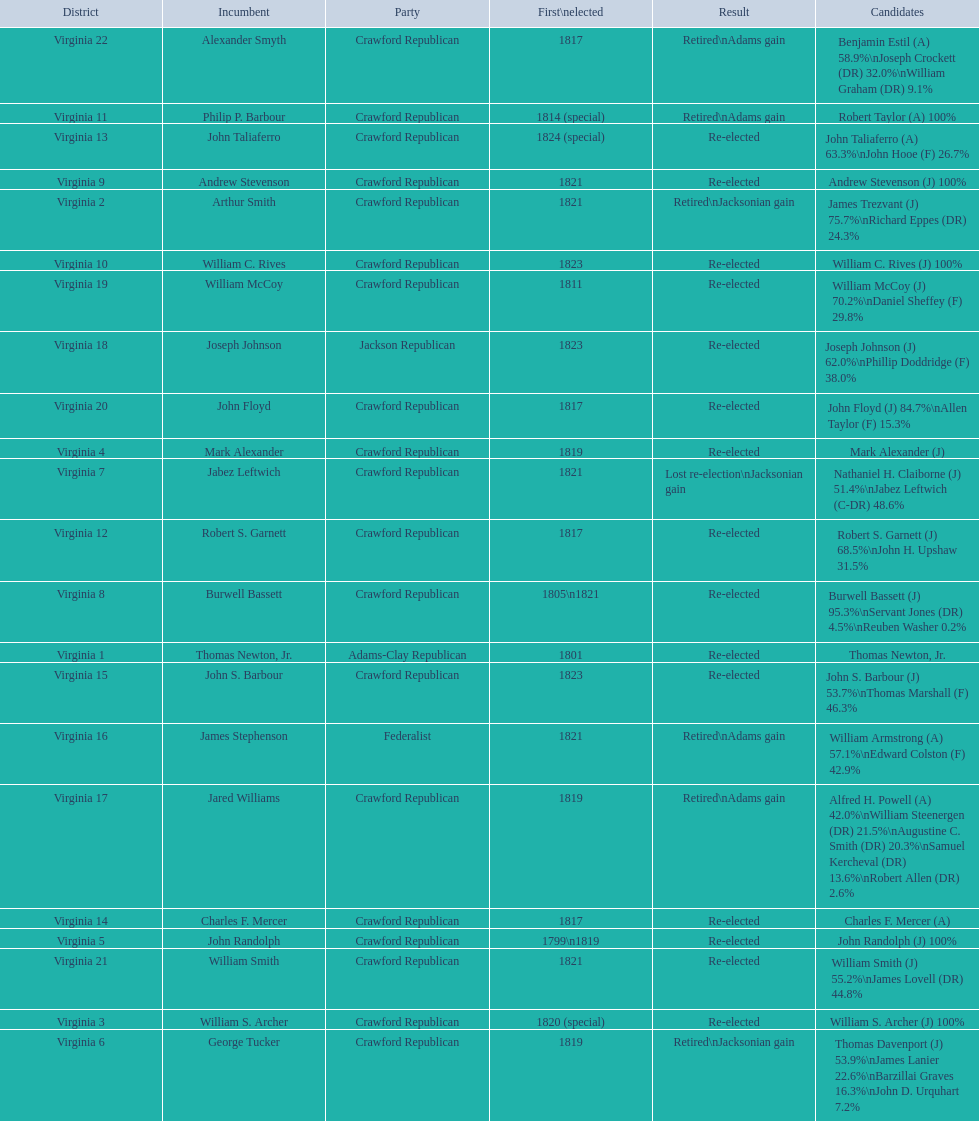Who were the incumbents of the 1824 united states house of representatives elections? Thomas Newton, Jr., Arthur Smith, William S. Archer, Mark Alexander, John Randolph, George Tucker, Jabez Leftwich, Burwell Bassett, Andrew Stevenson, William C. Rives, Philip P. Barbour, Robert S. Garnett, John Taliaferro, Charles F. Mercer, John S. Barbour, James Stephenson, Jared Williams, Joseph Johnson, William McCoy, John Floyd, William Smith, Alexander Smyth. And who were the candidates? Thomas Newton, Jr., James Trezvant (J) 75.7%\nRichard Eppes (DR) 24.3%, William S. Archer (J) 100%, Mark Alexander (J), John Randolph (J) 100%, Thomas Davenport (J) 53.9%\nJames Lanier 22.6%\nBarzillai Graves 16.3%\nJohn D. Urquhart 7.2%, Nathaniel H. Claiborne (J) 51.4%\nJabez Leftwich (C-DR) 48.6%, Burwell Bassett (J) 95.3%\nServant Jones (DR) 4.5%\nReuben Washer 0.2%, Andrew Stevenson (J) 100%, William C. Rives (J) 100%, Robert Taylor (A) 100%, Robert S. Garnett (J) 68.5%\nJohn H. Upshaw 31.5%, John Taliaferro (A) 63.3%\nJohn Hooe (F) 26.7%, Charles F. Mercer (A), John S. Barbour (J) 53.7%\nThomas Marshall (F) 46.3%, William Armstrong (A) 57.1%\nEdward Colston (F) 42.9%, Alfred H. Powell (A) 42.0%\nWilliam Steenergen (DR) 21.5%\nAugustine C. Smith (DR) 20.3%\nSamuel Kercheval (DR) 13.6%\nRobert Allen (DR) 2.6%, Joseph Johnson (J) 62.0%\nPhillip Doddridge (F) 38.0%, William McCoy (J) 70.2%\nDaniel Sheffey (F) 29.8%, John Floyd (J) 84.7%\nAllen Taylor (F) 15.3%, William Smith (J) 55.2%\nJames Lovell (DR) 44.8%, Benjamin Estil (A) 58.9%\nJoseph Crockett (DR) 32.0%\nWilliam Graham (DR) 9.1%. What were the results of their elections? Re-elected, Retired\nJacksonian gain, Re-elected, Re-elected, Re-elected, Retired\nJacksonian gain, Lost re-election\nJacksonian gain, Re-elected, Re-elected, Re-elected, Retired\nAdams gain, Re-elected, Re-elected, Re-elected, Re-elected, Retired\nAdams gain, Retired\nAdams gain, Re-elected, Re-elected, Re-elected, Re-elected, Retired\nAdams gain. And which jacksonian won over 76%? Arthur Smith. 